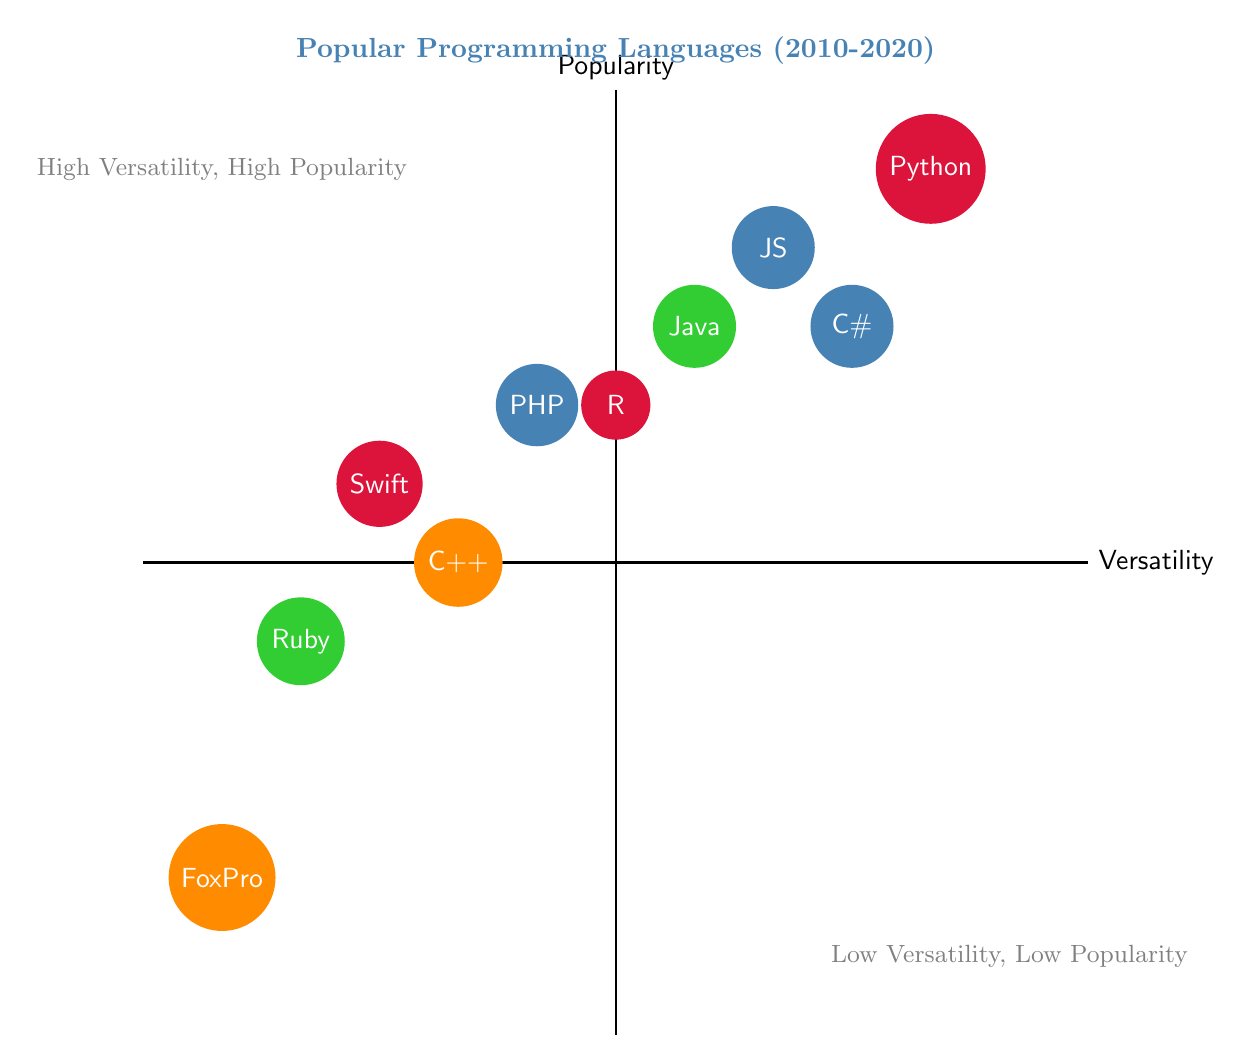What programming language is positioned in the lowest quadrant? The lowest quadrant represents low popularity and low versatility, which in this diagram corresponds to FoxPro, as it is the only language in that region.
Answer: FoxPro Which programming languages are classified as having high popularity? By examining the diagram, the languages located in the high popularity zone are JavaScript, Python, Java, C#, and R.
Answer: JavaScript, Python, Java, C#, R How many languages are shown in the quadrant chart? Counting all the nodes depicted in the diagram, there are a total of ten programming languages represented.
Answer: Ten Which language has medium versatility and high popularity? The only programming language that fits the medium versatility and high popularity category in the diagram is C#.
Answer: C# In which quadrant does Ruby fall? Ruby is positioned in the low popularity and medium versatility quadrant, as indicated by its location in the lower left area of the chart.
Answer: Low Popularity, Medium Versatility What can be identified as the axis representing versatility? The horizontal axis of the diagram clearly indicates versatility, which accommodates languages based on their adaptability for various use cases.
Answer: Versatility How many programming languages are used primarily for web development? In the diagram, the languages identified with web development as a use case are JavaScript, PHP, and Ruby, totaling three languages.
Answer: Three Which programming languages are located in the high versatility, high popularity quadrant? The languages depicted in this quadrant include JavaScript and Python, which are both recognized for their wide range of applications and high user popularity.
Answer: JavaScript, Python Is FoxPro utilized for mobile app development? From the data presented, FoxPro is solely listed for database management and does not appear in the mobile app development use case categorizations.
Answer: No 